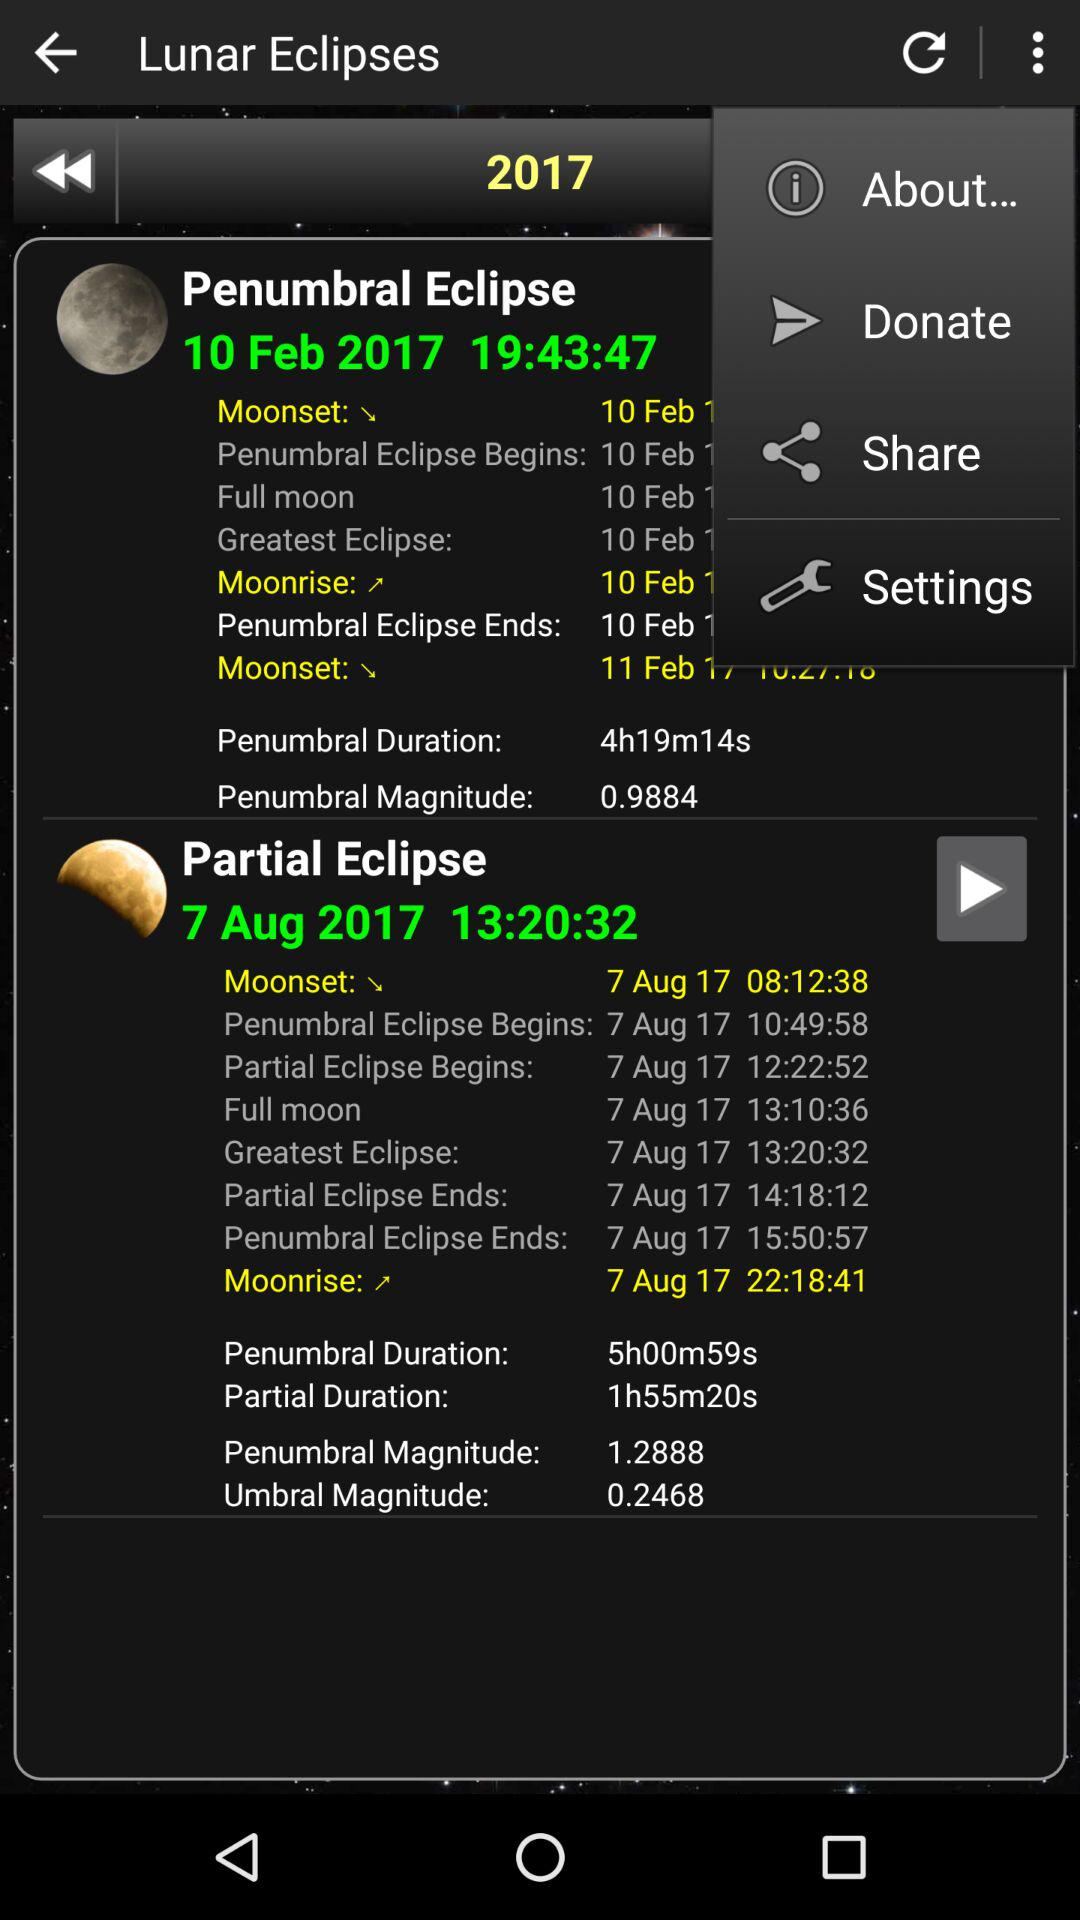What is the time of the "Partial Eclipse"? The time is 13:20:32. 